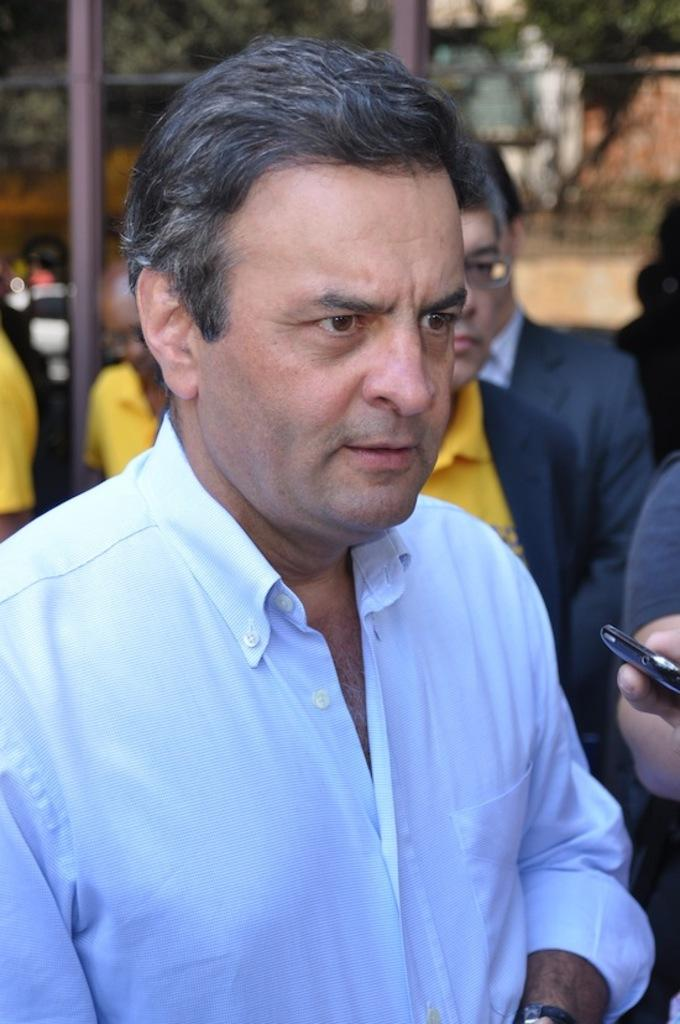What can be seen in the image involving people? There are people standing in the image. What object is being held by a human hand in the image? A mobile is being held by a human hand in the image. What type of natural elements are visible in the image? Trees are visible in the image. What type of man-made structures can be seen in the image? Metal poles are present in the image. What can be seen in the background of the image? There appears to be a wall in the background of the image. What type of sheet is being used by the people in the image? There is no sheet present in the image; the people are standing without any visible sheets. 